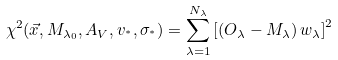<formula> <loc_0><loc_0><loc_500><loc_500>\chi ^ { 2 } ( \vec { x } , M _ { \lambda _ { 0 } } , A _ { V } , v _ { ^ { * } } , \sigma _ { ^ { * } } ) = \sum _ { \lambda = 1 } ^ { N _ { \lambda } } \left [ \left ( O _ { \lambda } - M _ { \lambda } \right ) w _ { \lambda } \right ] ^ { 2 }</formula> 